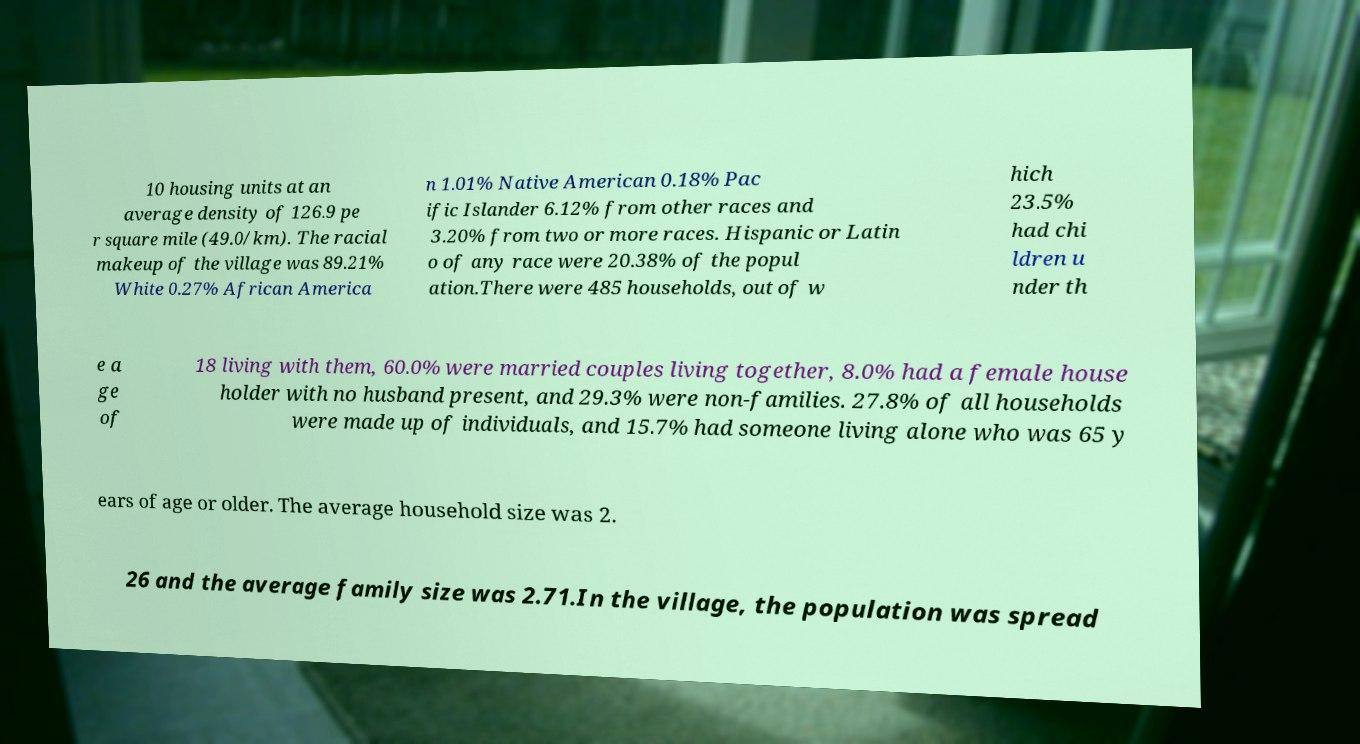What messages or text are displayed in this image? I need them in a readable, typed format. 10 housing units at an average density of 126.9 pe r square mile (49.0/km). The racial makeup of the village was 89.21% White 0.27% African America n 1.01% Native American 0.18% Pac ific Islander 6.12% from other races and 3.20% from two or more races. Hispanic or Latin o of any race were 20.38% of the popul ation.There were 485 households, out of w hich 23.5% had chi ldren u nder th e a ge of 18 living with them, 60.0% were married couples living together, 8.0% had a female house holder with no husband present, and 29.3% were non-families. 27.8% of all households were made up of individuals, and 15.7% had someone living alone who was 65 y ears of age or older. The average household size was 2. 26 and the average family size was 2.71.In the village, the population was spread 